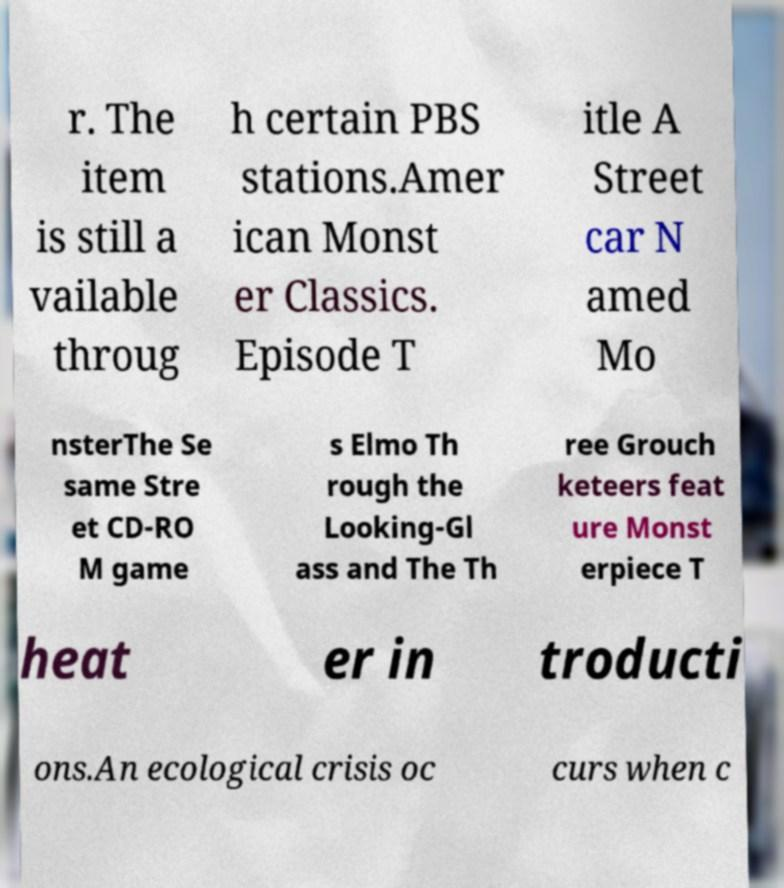Could you extract and type out the text from this image? r. The item is still a vailable throug h certain PBS stations.Amer ican Monst er Classics. Episode T itle A Street car N amed Mo nsterThe Se same Stre et CD-RO M game s Elmo Th rough the Looking-Gl ass and The Th ree Grouch keteers feat ure Monst erpiece T heat er in troducti ons.An ecological crisis oc curs when c 